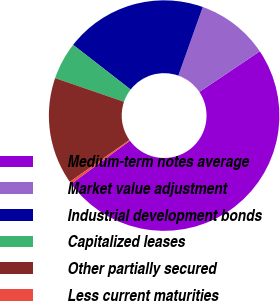<chart> <loc_0><loc_0><loc_500><loc_500><pie_chart><fcel>Medium-term notes average<fcel>Market value adjustment<fcel>Industrial development bonds<fcel>Capitalized leases<fcel>Other partially secured<fcel>Less current maturities<nl><fcel>49.32%<fcel>10.14%<fcel>19.93%<fcel>5.24%<fcel>15.03%<fcel>0.34%<nl></chart> 